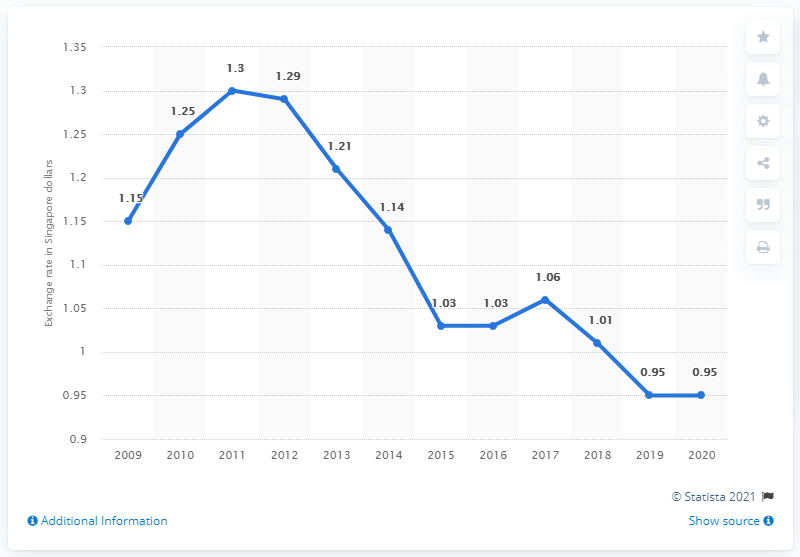Identify some key points in this picture. In 2020, the average exchange rate from Singapore dollar to Australian dollar was 0.95. In 2020, the average exchange rate from Singapore dollars to Australian dollars was 0.95. 